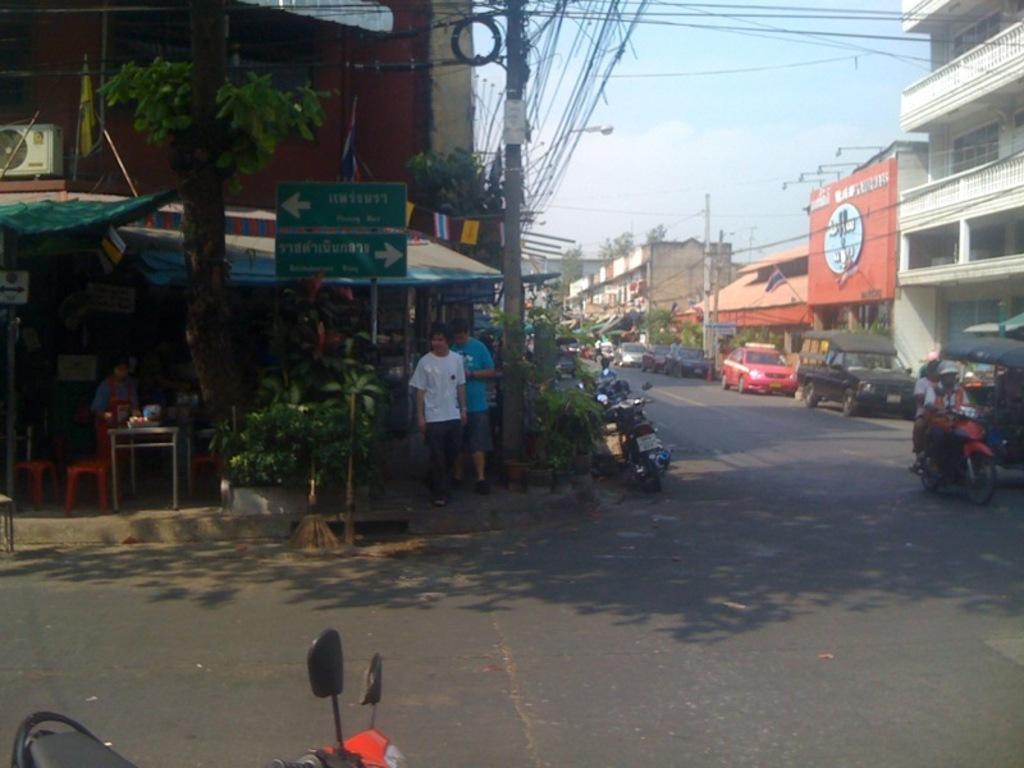Describe this image in one or two sentences. This image consists of two persons standing. At the bottom, there is a road. There are many vehicles parked on the road. To the left and right, there are buildings. At the bottom left, there is a bike. 